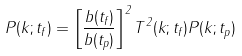Convert formula to latex. <formula><loc_0><loc_0><loc_500><loc_500>P ( k ; t _ { f } ) = \left [ \frac { b ( t _ { f } ) } { b ( t _ { p } ) } \right ] ^ { 2 } T ^ { 2 } ( k ; t _ { f } ) P ( k ; t _ { p } )</formula> 